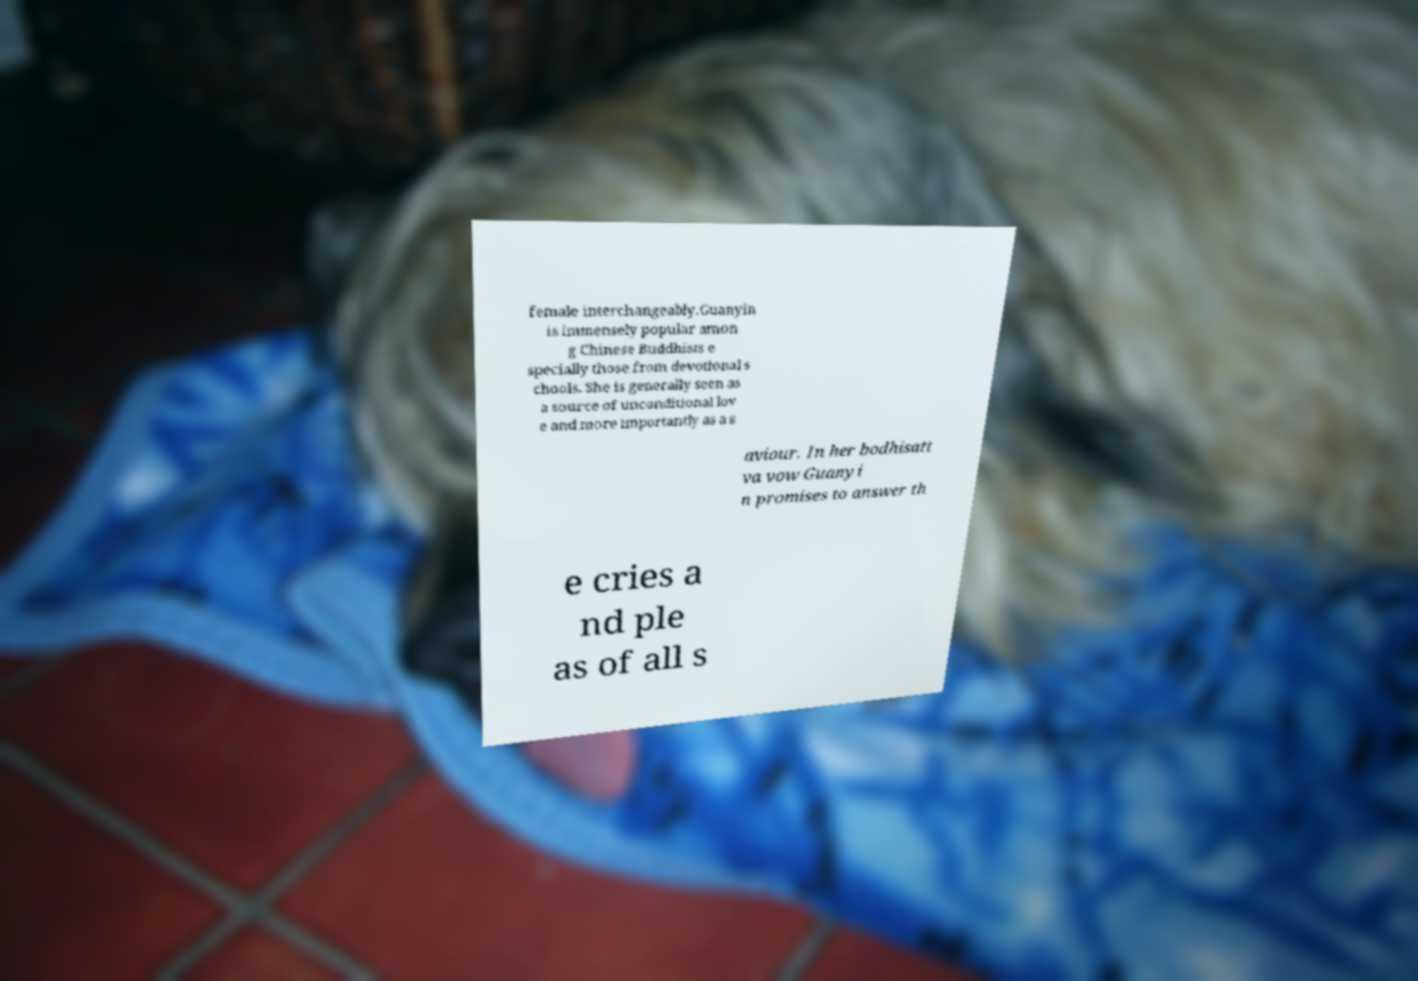There's text embedded in this image that I need extracted. Can you transcribe it verbatim? female interchangeably.Guanyin is immensely popular amon g Chinese Buddhists e specially those from devotional s chools. She is generally seen as a source of unconditional lov e and more importantly as a s aviour. In her bodhisatt va vow Guanyi n promises to answer th e cries a nd ple as of all s 